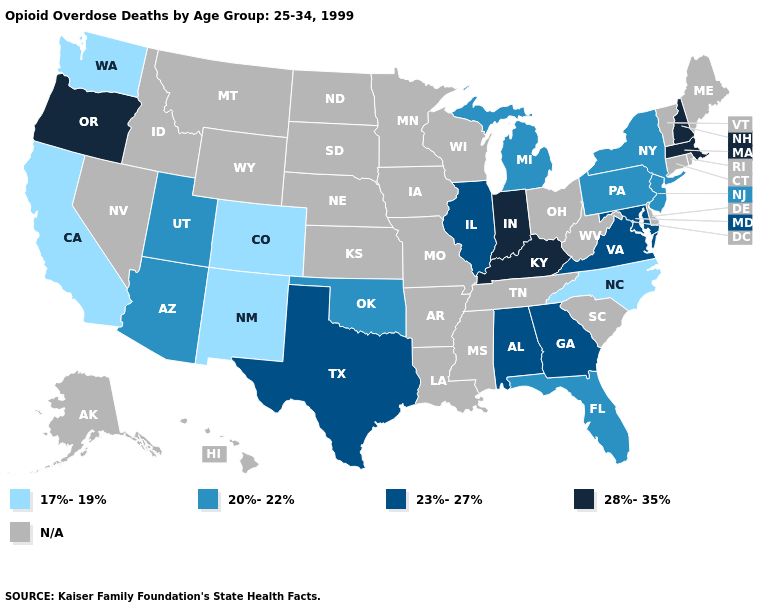What is the value of Kansas?
Short answer required. N/A. Is the legend a continuous bar?
Give a very brief answer. No. What is the highest value in the West ?
Short answer required. 28%-35%. Among the states that border Indiana , does Michigan have the lowest value?
Concise answer only. Yes. What is the value of Vermont?
Answer briefly. N/A. Which states have the lowest value in the USA?
Short answer required. California, Colorado, New Mexico, North Carolina, Washington. What is the value of New Mexico?
Concise answer only. 17%-19%. Does New York have the lowest value in the USA?
Keep it brief. No. Which states hav the highest value in the South?
Concise answer only. Kentucky. Does the map have missing data?
Answer briefly. Yes. What is the highest value in the USA?
Keep it brief. 28%-35%. Does Michigan have the lowest value in the MidWest?
Be succinct. Yes. Among the states that border Nevada , does Arizona have the lowest value?
Write a very short answer. No. What is the lowest value in the MidWest?
Give a very brief answer. 20%-22%. Among the states that border Virginia , does Maryland have the lowest value?
Be succinct. No. 